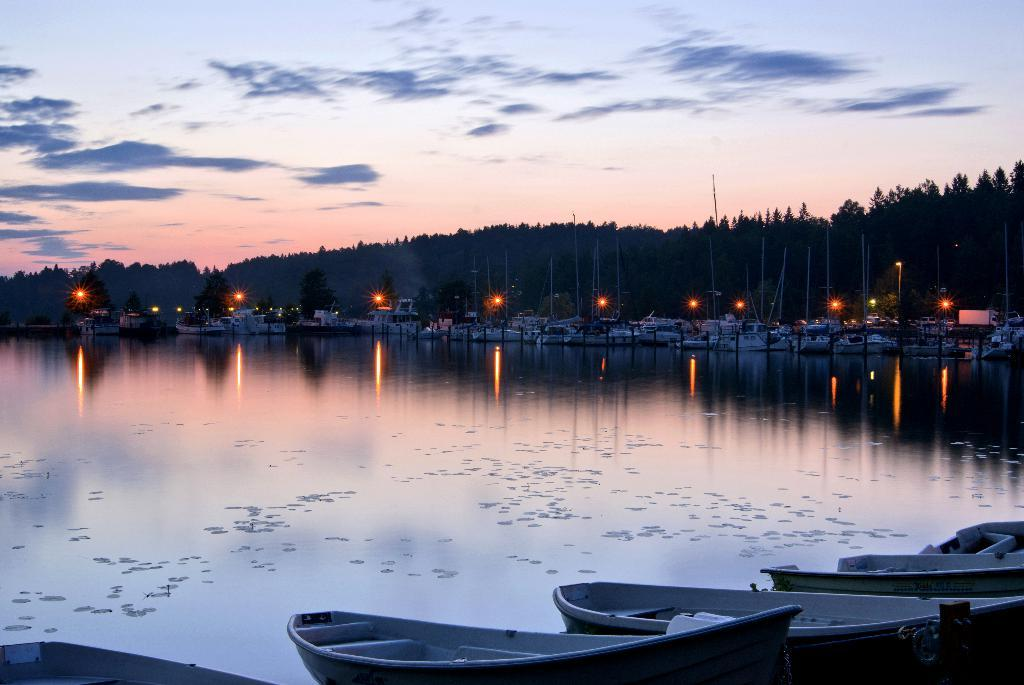What is located at the bottom of the image? There are boats at the bottom of the image. What is the primary element visible in the image? There is water visible in the image. What can be seen in the background of the image? Ships, lights, poles, trees, and other objects are present in the background of the image. What is visible in the sky in the background of the image? Clouds are visible in the sky in the background of the image. Can you tell me how many jelly cubes are floating in the water in the image? There are no jelly cubes present in the image; it features boats, water, and various objects in the background. Is there a kitten playing with the boats in the image? There is no kitten present in the image; it features boats, water, and various objects in the background. 